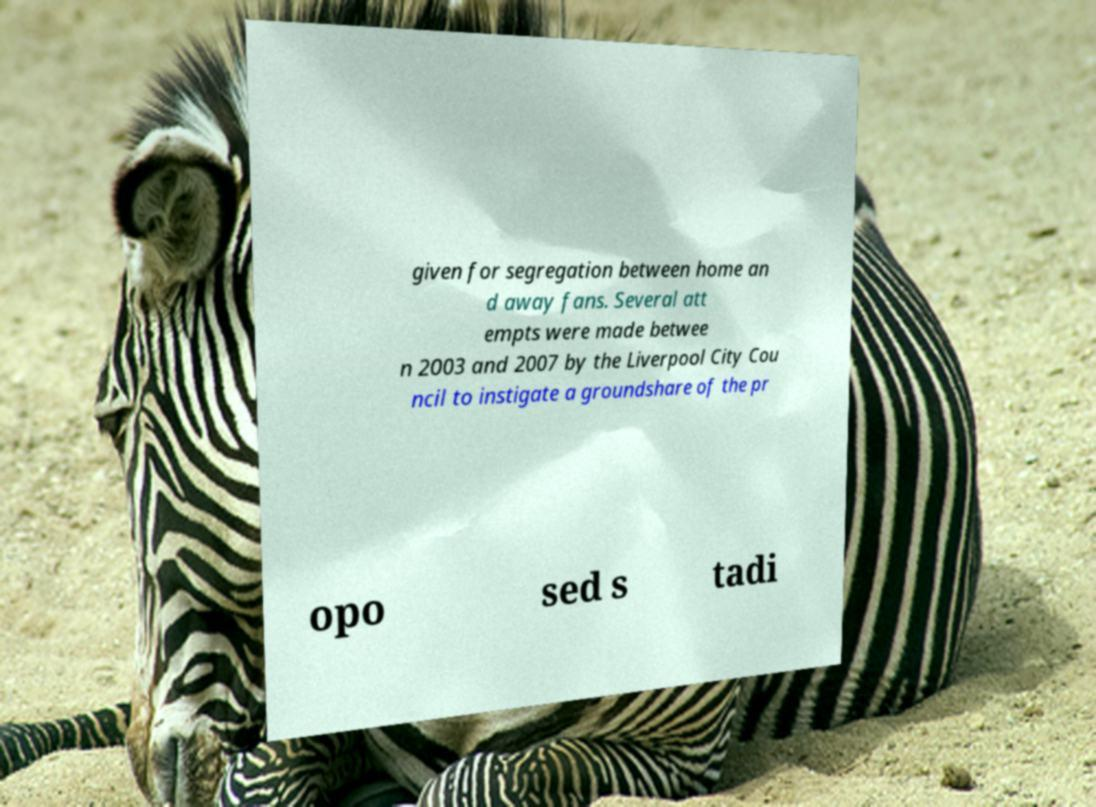Can you read and provide the text displayed in the image?This photo seems to have some interesting text. Can you extract and type it out for me? given for segregation between home an d away fans. Several att empts were made betwee n 2003 and 2007 by the Liverpool City Cou ncil to instigate a groundshare of the pr opo sed s tadi 